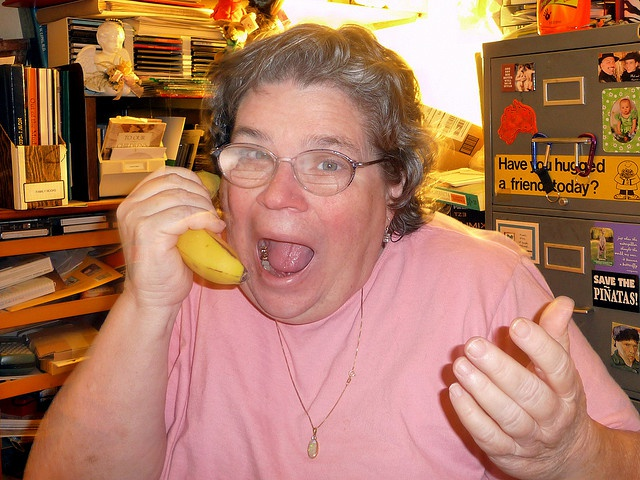Describe the objects in this image and their specific colors. I can see people in gray, lightpink, salmon, and brown tones, book in gray, black, tan, red, and gold tones, banana in gray, orange, brown, and gold tones, book in gray, tan, black, and maroon tones, and book in gray, olive, and tan tones in this image. 